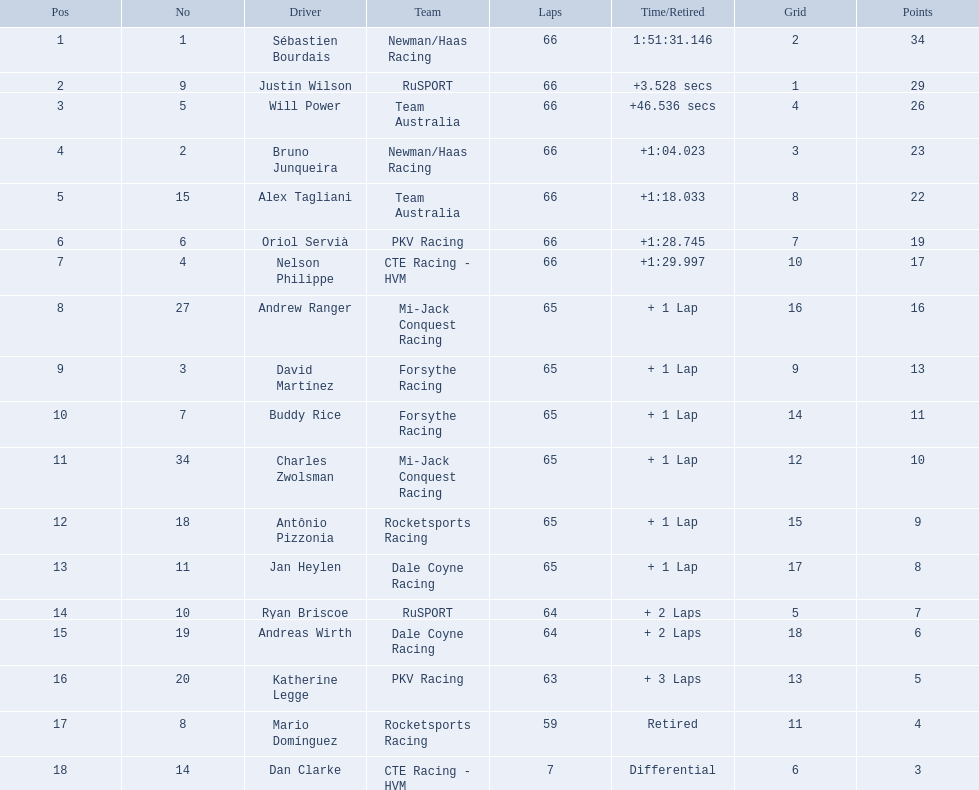What drivers started in the top 10? Sébastien Bourdais, Justin Wilson, Will Power, Bruno Junqueira, Alex Tagliani, Oriol Servià, Nelson Philippe, Ryan Briscoe, Dan Clarke. Which of those drivers completed all 66 laps? Sébastien Bourdais, Justin Wilson, Will Power, Bruno Junqueira, Alex Tagliani, Oriol Servià, Nelson Philippe. Whom of these did not drive for team australia? Sébastien Bourdais, Justin Wilson, Bruno Junqueira, Oriol Servià, Nelson Philippe. Which of these drivers finished more then a minuet after the winner? Bruno Junqueira, Oriol Servià, Nelson Philippe. Which of these drivers had the highest car number? Oriol Servià. 